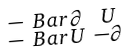<formula> <loc_0><loc_0><loc_500><loc_500>\begin{smallmatrix} - \ B a r { \partial } & U \\ - \ B a r { U } & - \partial \end{smallmatrix}</formula> 